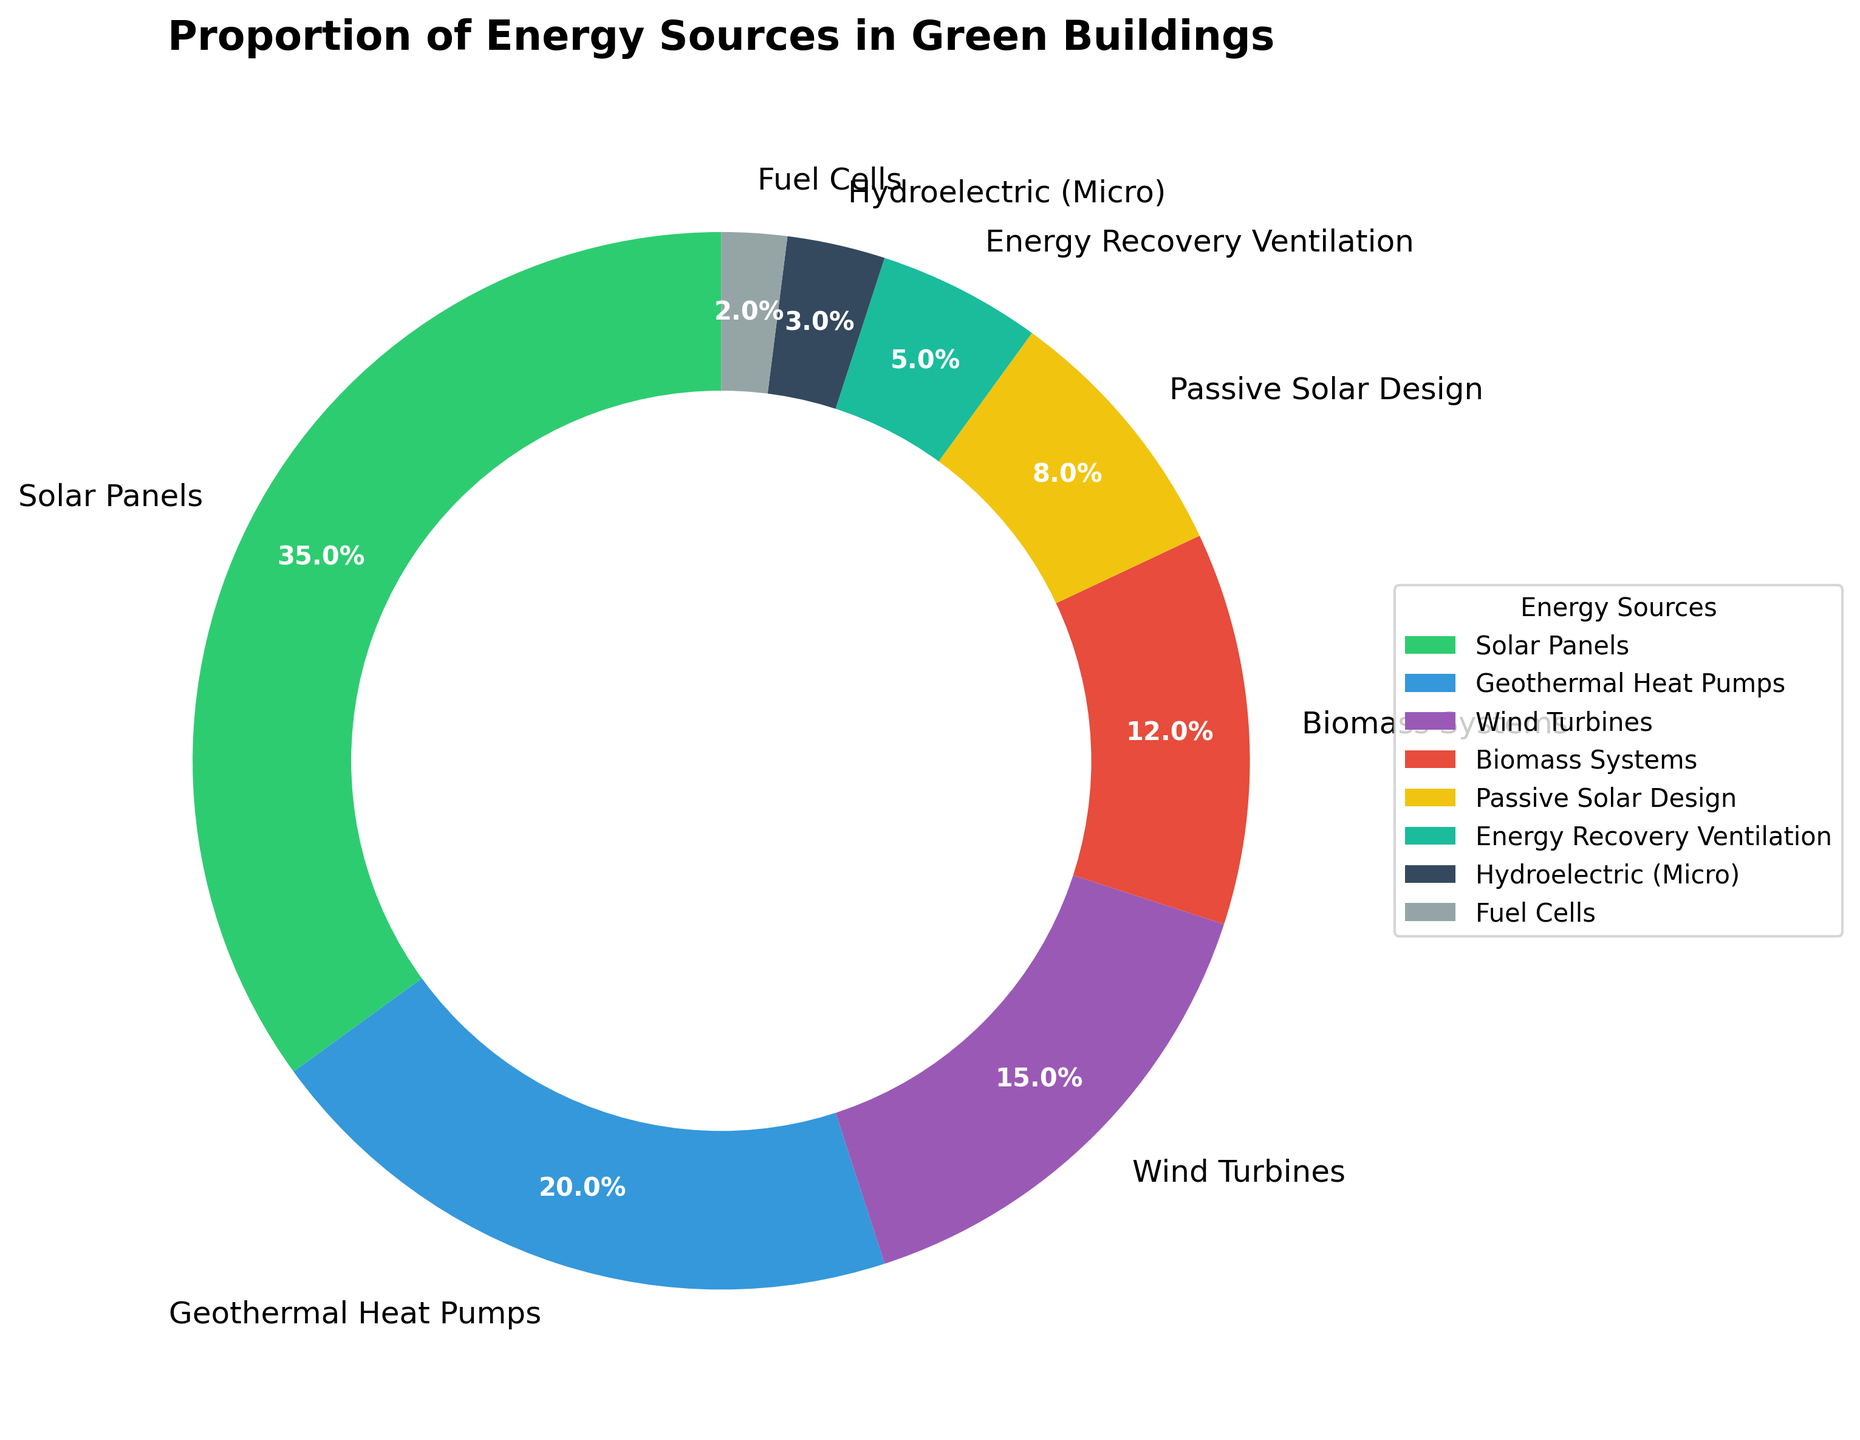Which energy source has the highest percentage in the pie chart? The energy source with the highest percentage is the one with the largest portion of the pie chart, labeled as 'Solar Panels' with 35%.
Answer: Solar Panels Which energy sources combined make up more than 50% of the energy usage? First, identify the percentages of each source: Solar Panels (35%), Geothermal Heat Pumps (20%), Wind Turbines (15%), Biomass Systems (12%), Passive Solar Design (8%), Energy Recovery Ventilation (5%), Hydroelectric (Micro) (3%), Fuel Cells (2%). Adding Solar Panels (35%) and Geothermal Heat Pumps (20%) yields 55%, which already surpasses 50%.
Answer: Solar Panels and Geothermal Heat Pumps How much more percentage does Solar Panels contribute compared to Wind Turbines? Solar Panels contribute 35% and Wind Turbines contribute 15%. The difference is 35% - 15%.
Answer: 20% What is the combined percentage of Biomass Systems, Passive Solar Design, and Energy Recovery Ventilation? The percentages for Biomass Systems, Passive Solar Design, and Energy Recovery Ventilation are 12%, 8%, and 5%, respectively. Adding them gives 12% + 8% + 5% = 25%.
Answer: 25% Which energy source uses the least proportion among those depicted? The smallest portion of the pie chart is labeled 'Fuel Cells' with 2%.
Answer: Fuel Cells How does the percentage usage of Geothermal Heat Pumps compare to that of Biomass Systems and Passive Solar Design combined? Geothermal Heat Pumps have a 20% usage. Biomass Systems and Passive Solar Design combined are 12% + 8% = 20%. Both usages are equal in percentage.
Answer: Equal If we wanted to combine Wind Turbines and all sources with a lower percentage than them, what would be the total percentage? Wind Turbines have 15%. The sources with lower percentages are Biomass Systems (12%), Passive Solar Design (8%), Energy Recovery Ventilation (5%), Hydroelectric (Micro) (3%), and Fuel Cells (2%). Adding them: 15% + 12% + 8% + 5% + 3% + 2% = 45%.
Answer: 45% Which energy source in the pie chart is represented in yellow color? By process of elimination and referring to the chart, Passive Solar Design is represented in yellow.
Answer: Passive Solar Design 